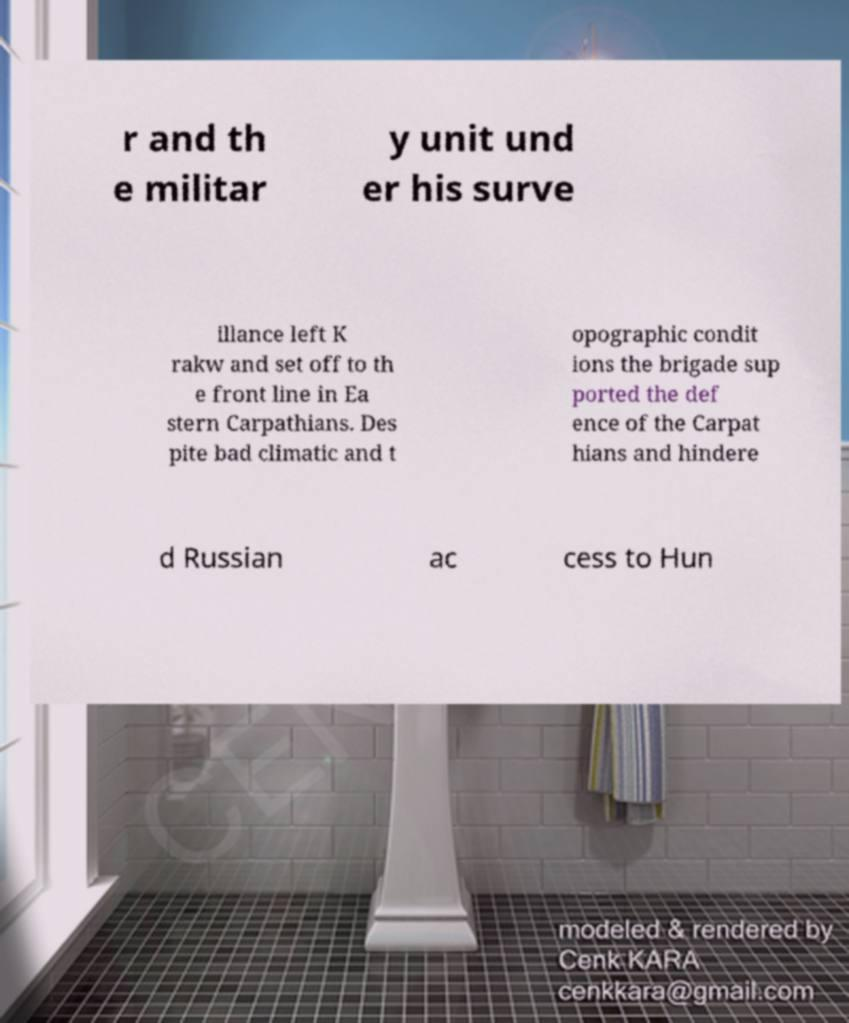Please read and relay the text visible in this image. What does it say? r and th e militar y unit und er his surve illance left K rakw and set off to th e front line in Ea stern Carpathians. Des pite bad climatic and t opographic condit ions the brigade sup ported the def ence of the Carpat hians and hindere d Russian ac cess to Hun 